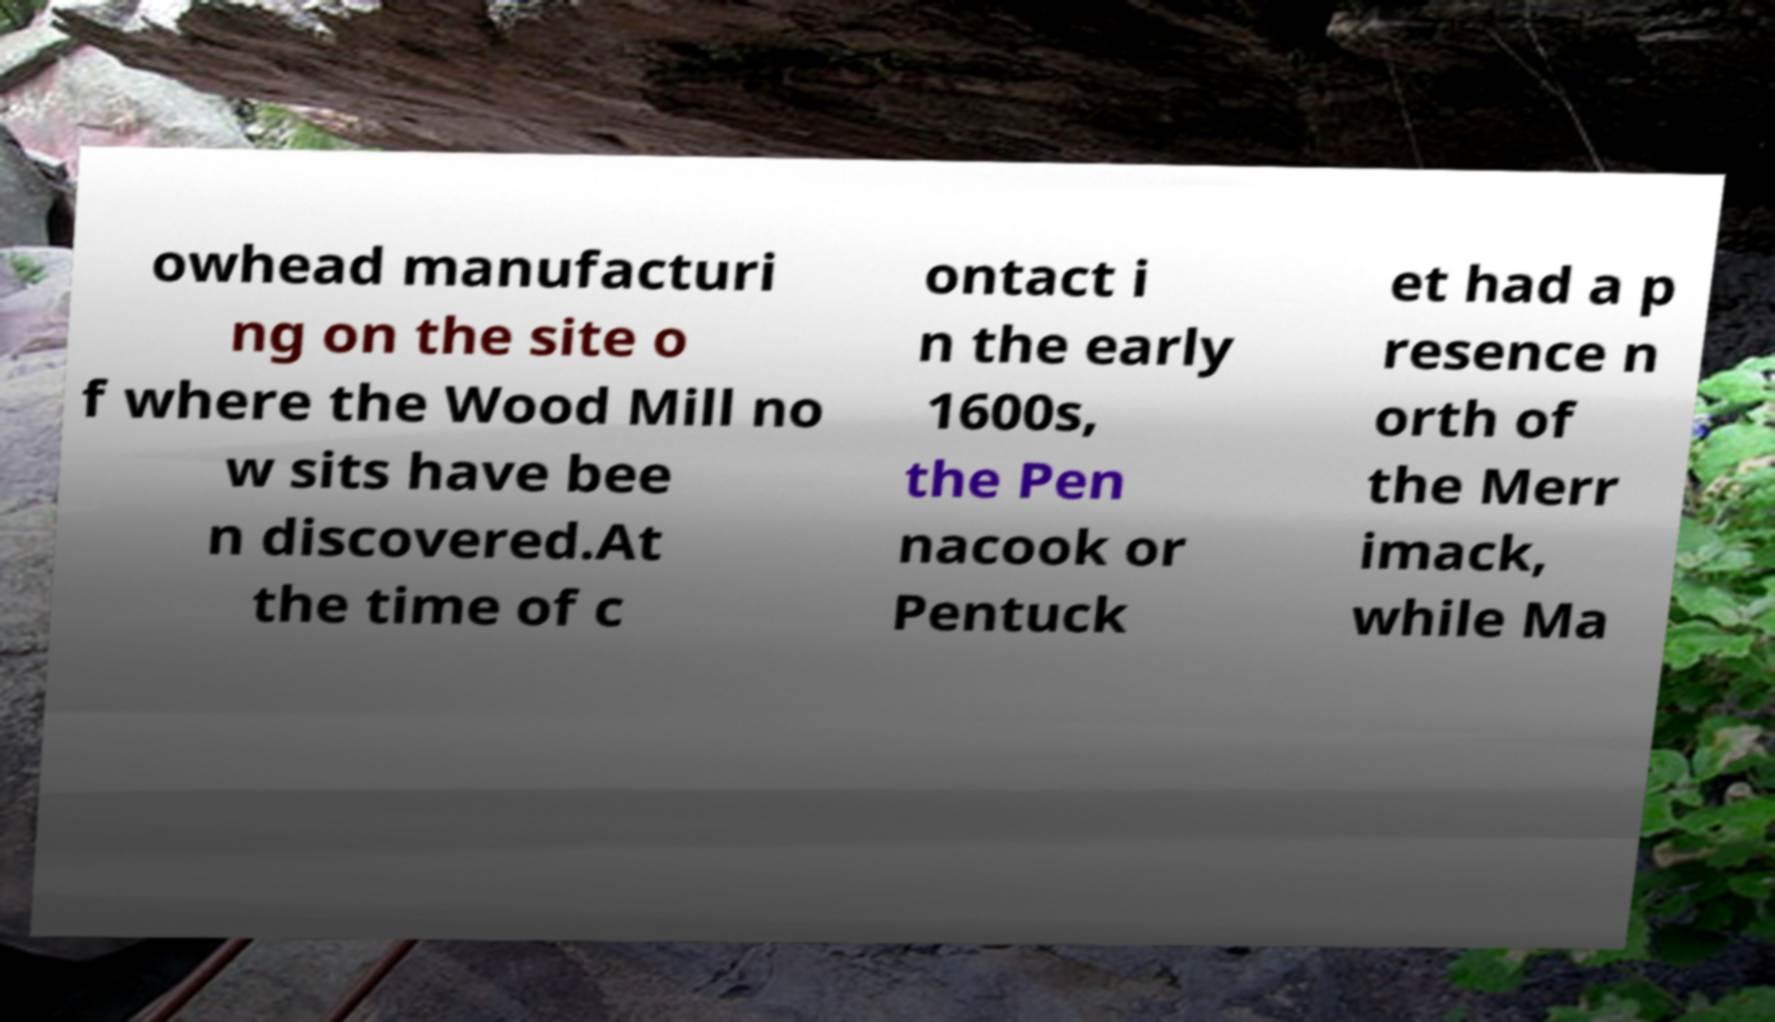For documentation purposes, I need the text within this image transcribed. Could you provide that? owhead manufacturi ng on the site o f where the Wood Mill no w sits have bee n discovered.At the time of c ontact i n the early 1600s, the Pen nacook or Pentuck et had a p resence n orth of the Merr imack, while Ma 